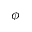Convert formula to latex. <formula><loc_0><loc_0><loc_500><loc_500>\phi</formula> 